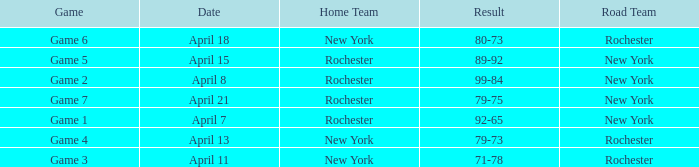Which Home Team has a Road Team of rochester, and a Result of 71-78? New York. 